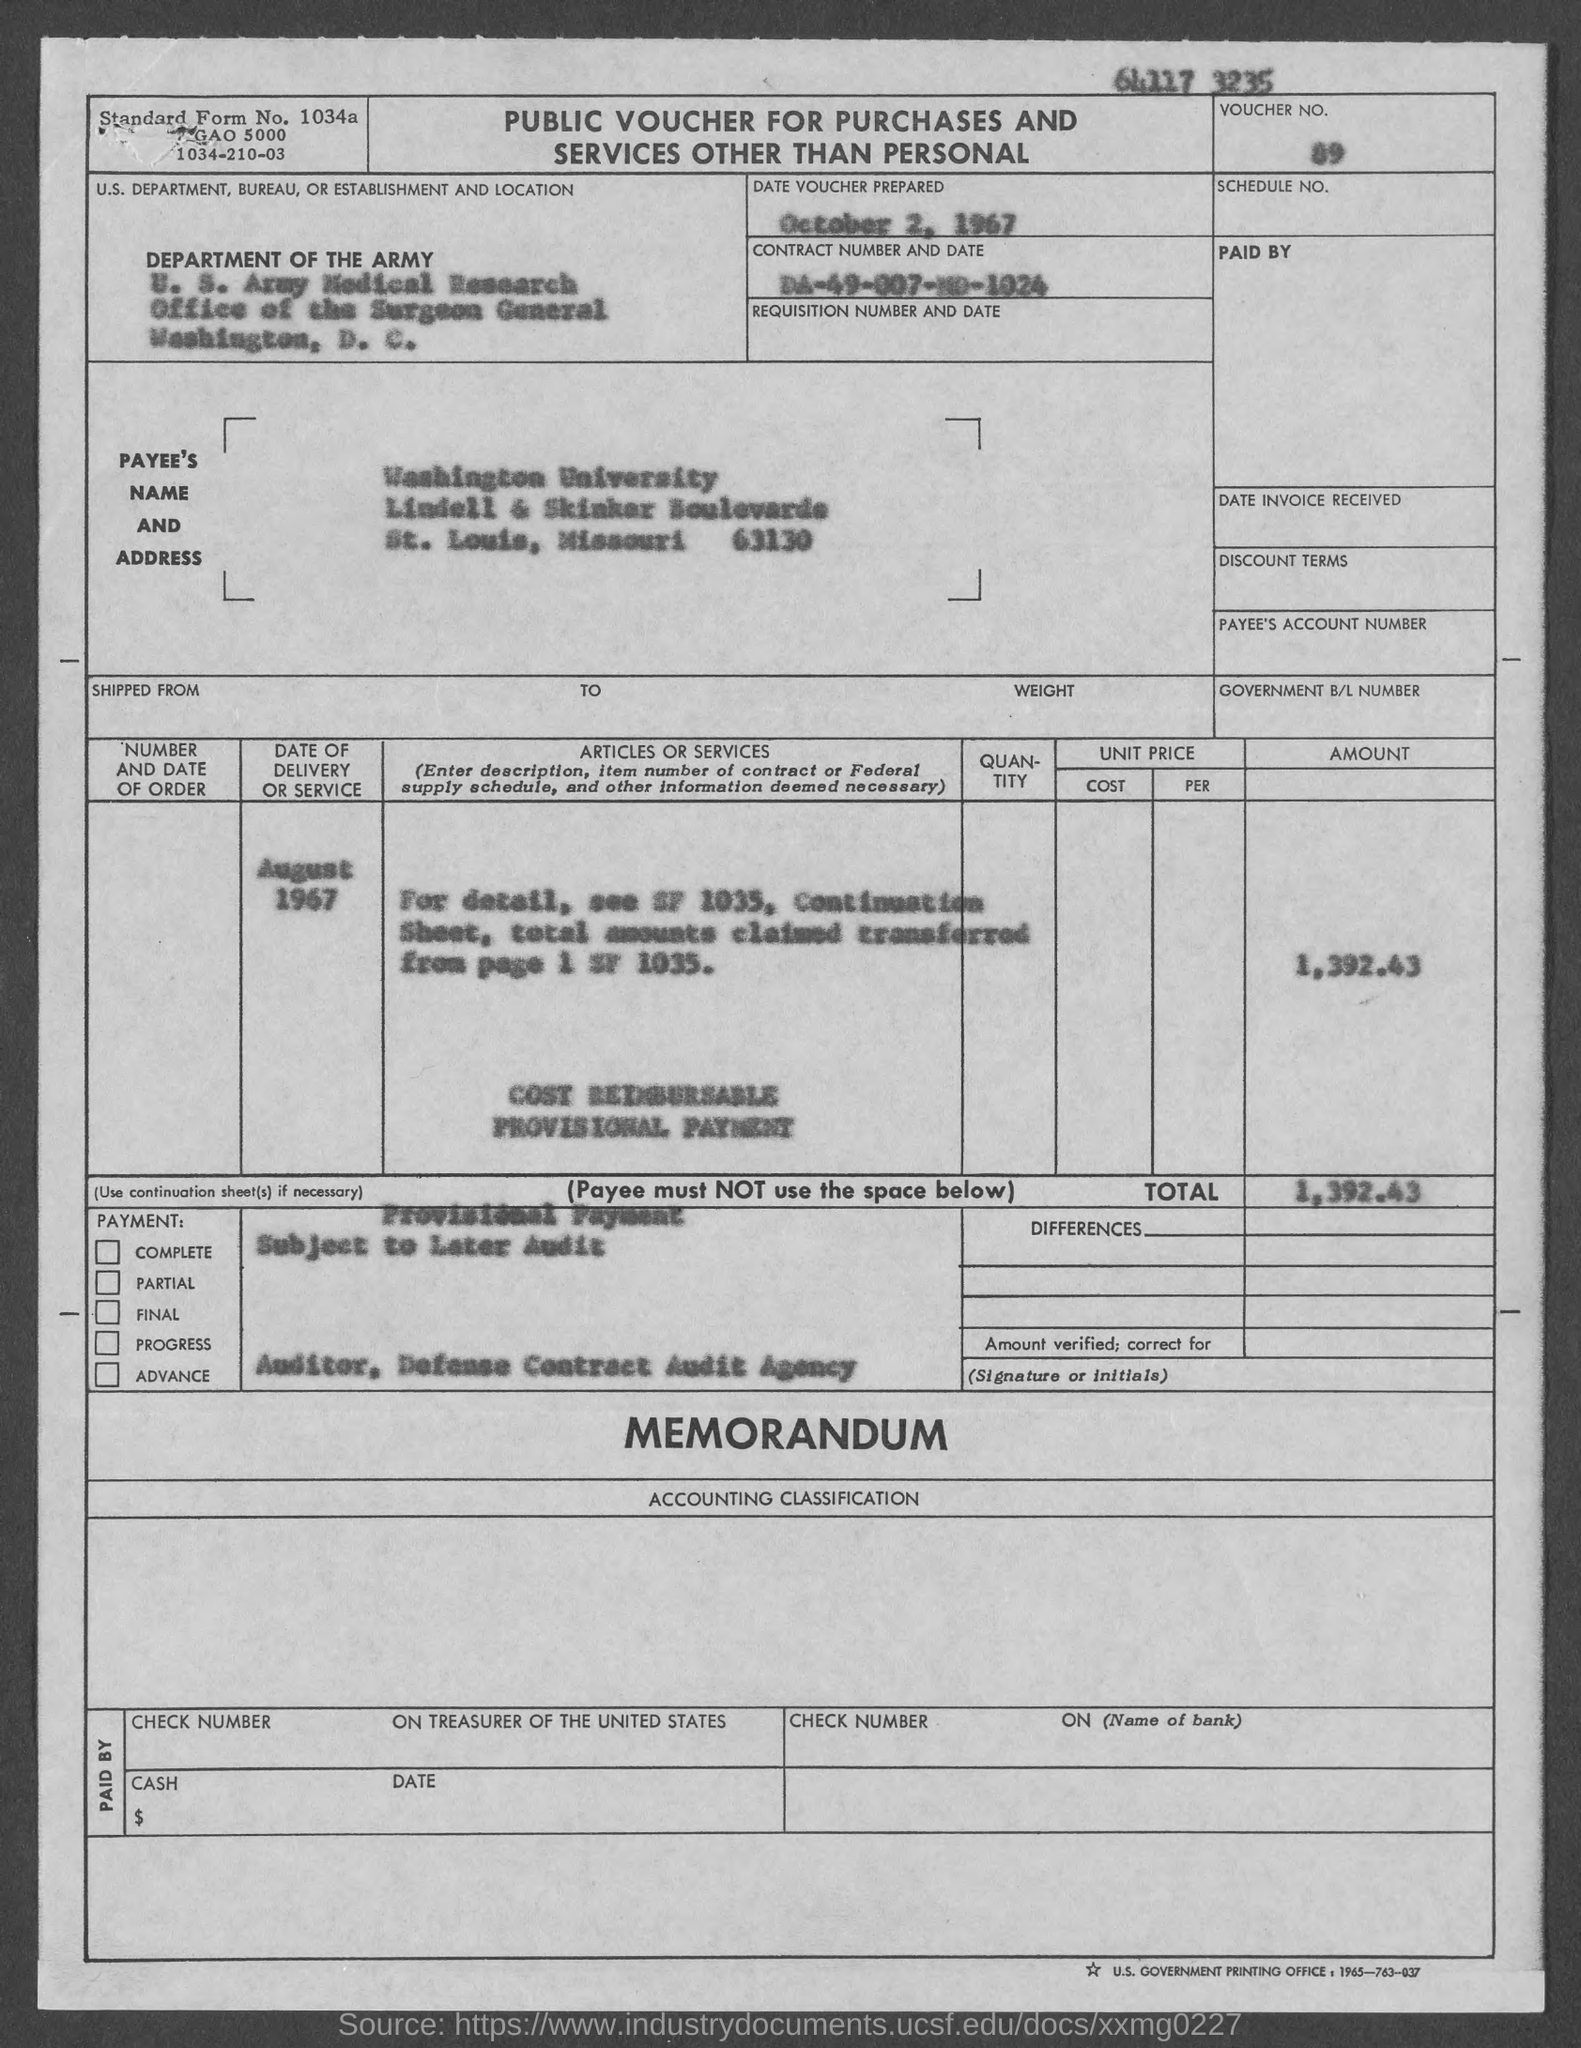What type of voucher is given here?
Provide a succinct answer. PUBLIC VOUCHER FOR PURCHASES AND SERVICES OTHER THAN PERSONAL. What is the Standard Form No. given in the voucher?
Your answer should be very brief. 1034a. What is the Voucher No. mentioned in the document?
Your answer should be compact. 89. What is the Contract No. given in the voucher?
Provide a succinct answer. DA-49-007-MD-1024. What is the date of voucher prepared?
Provide a succinct answer. October 2, 1967. What is the payee's name given in the voucher?
Your response must be concise. Washington University. What is the date of delivery of service mentioned in the voucher?
Provide a short and direct response. August 1967. What is the total amount mentioned in the voucher?
Your response must be concise. 1,392.43. 